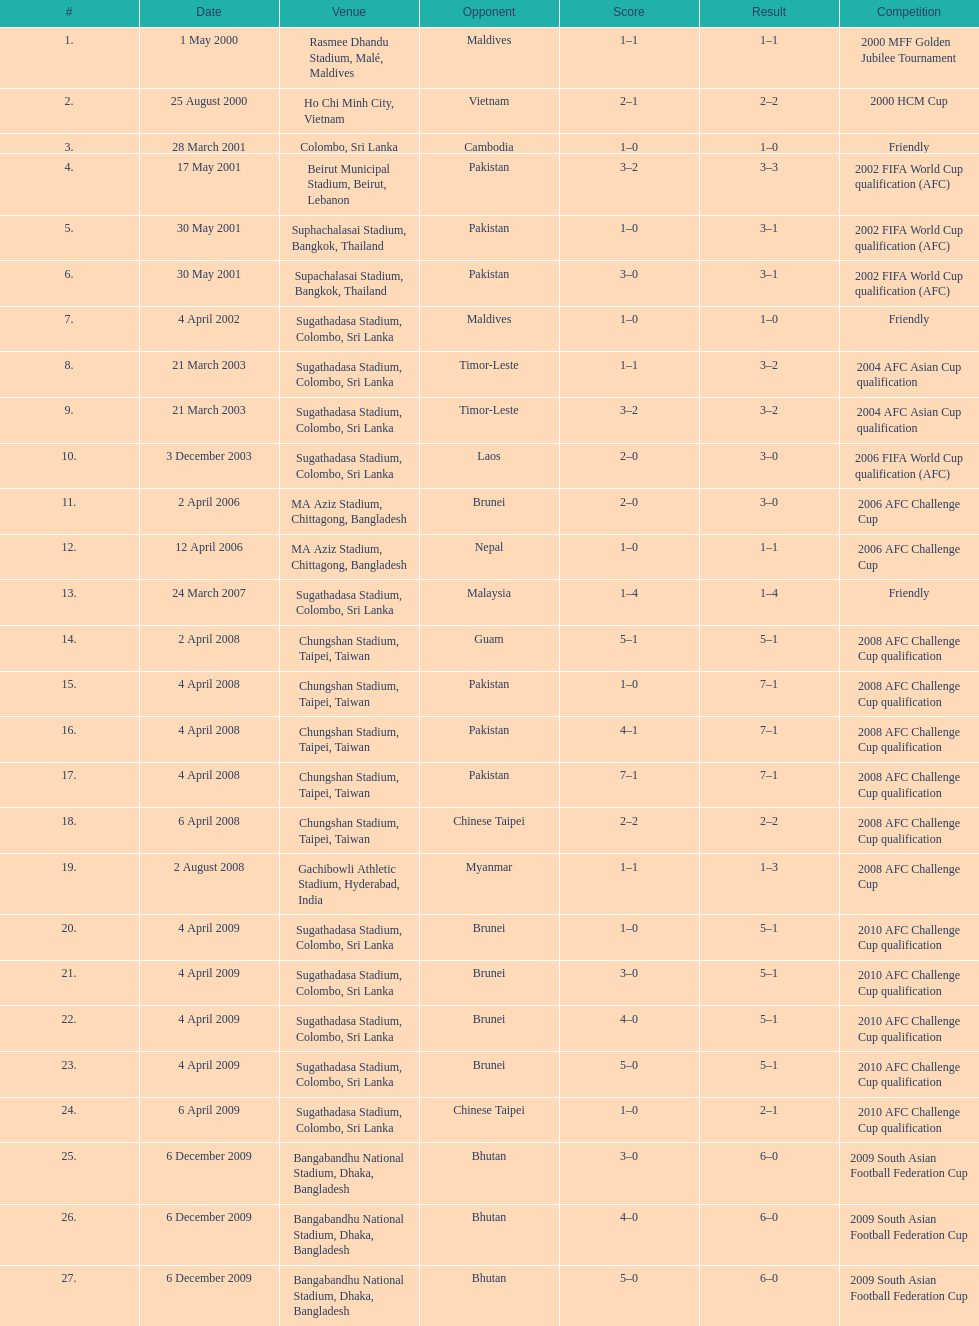Which venue has the largest result Chungshan Stadium, Taipei, Taiwan. 